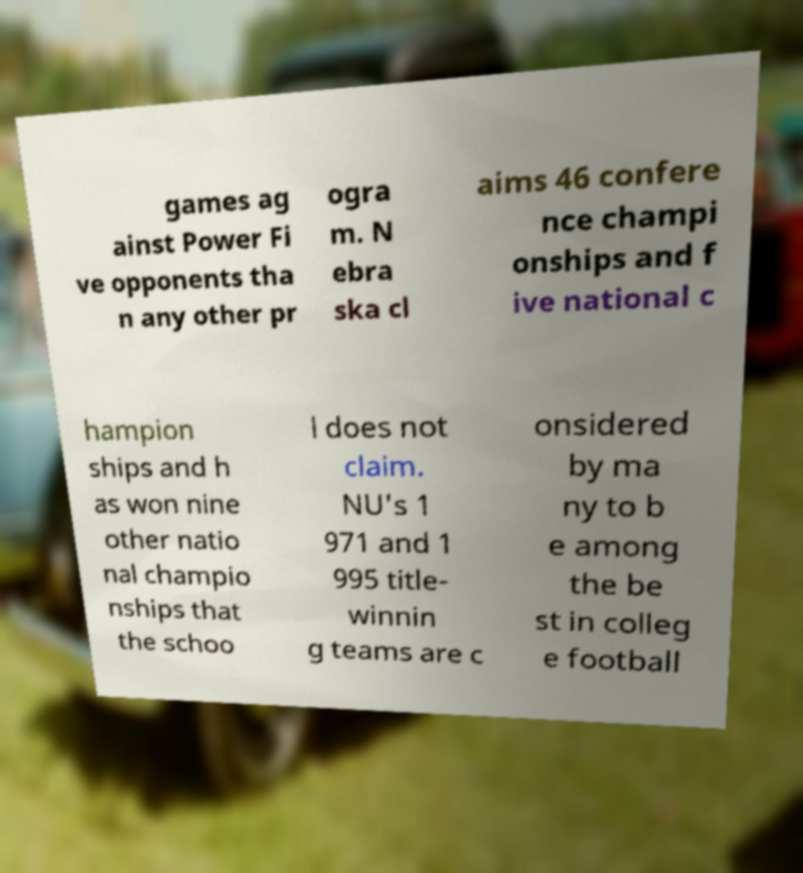There's text embedded in this image that I need extracted. Can you transcribe it verbatim? games ag ainst Power Fi ve opponents tha n any other pr ogra m. N ebra ska cl aims 46 confere nce champi onships and f ive national c hampion ships and h as won nine other natio nal champio nships that the schoo l does not claim. NU's 1 971 and 1 995 title- winnin g teams are c onsidered by ma ny to b e among the be st in colleg e football 